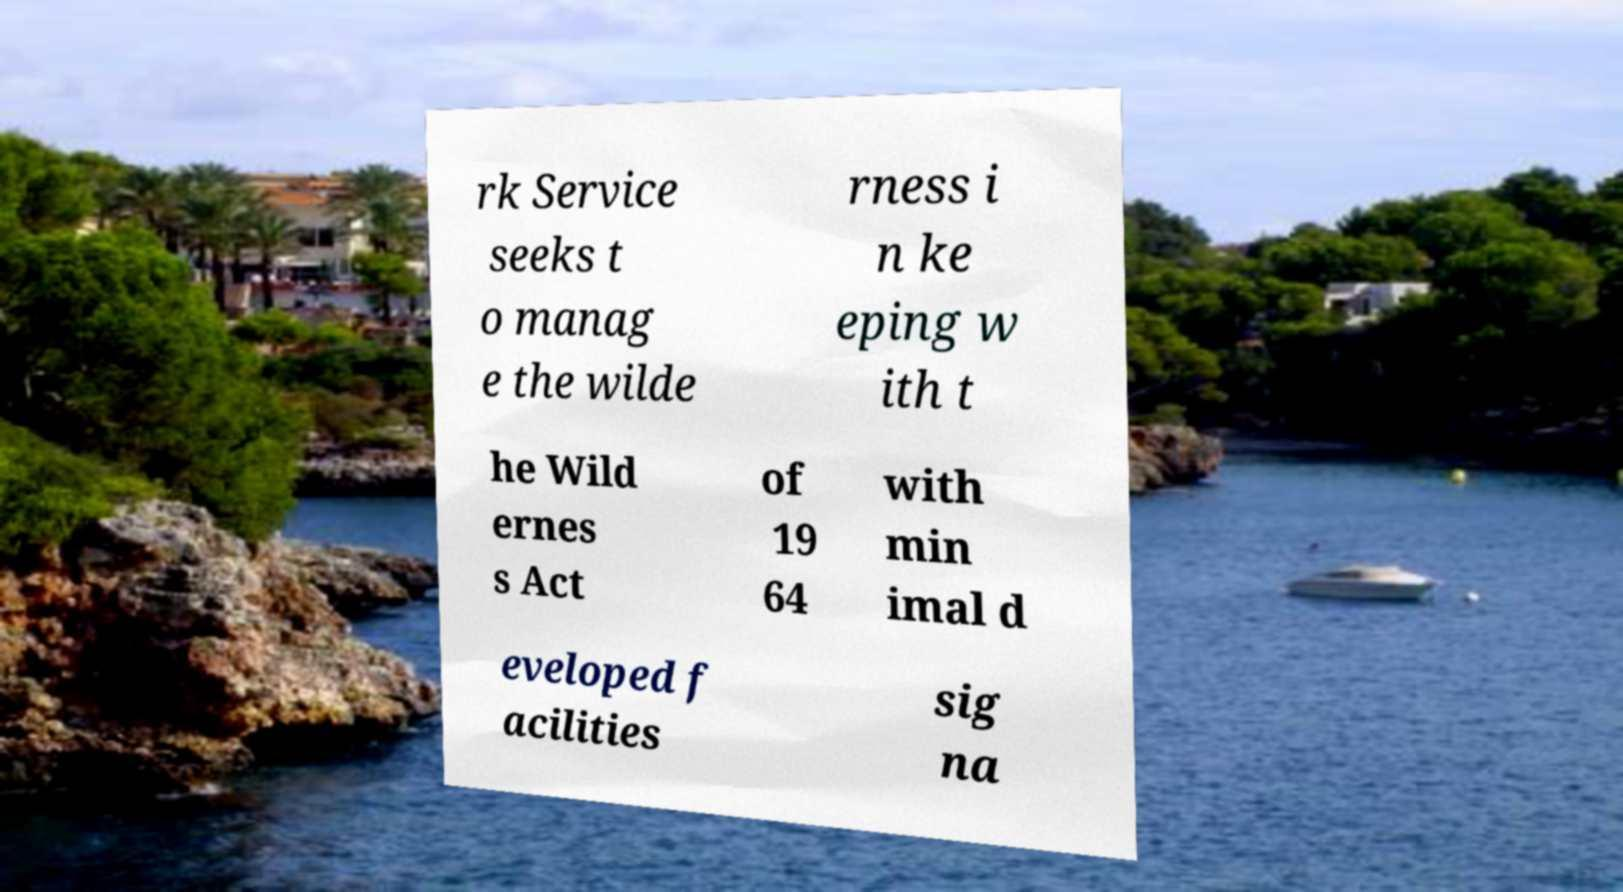There's text embedded in this image that I need extracted. Can you transcribe it verbatim? rk Service seeks t o manag e the wilde rness i n ke eping w ith t he Wild ernes s Act of 19 64 with min imal d eveloped f acilities sig na 